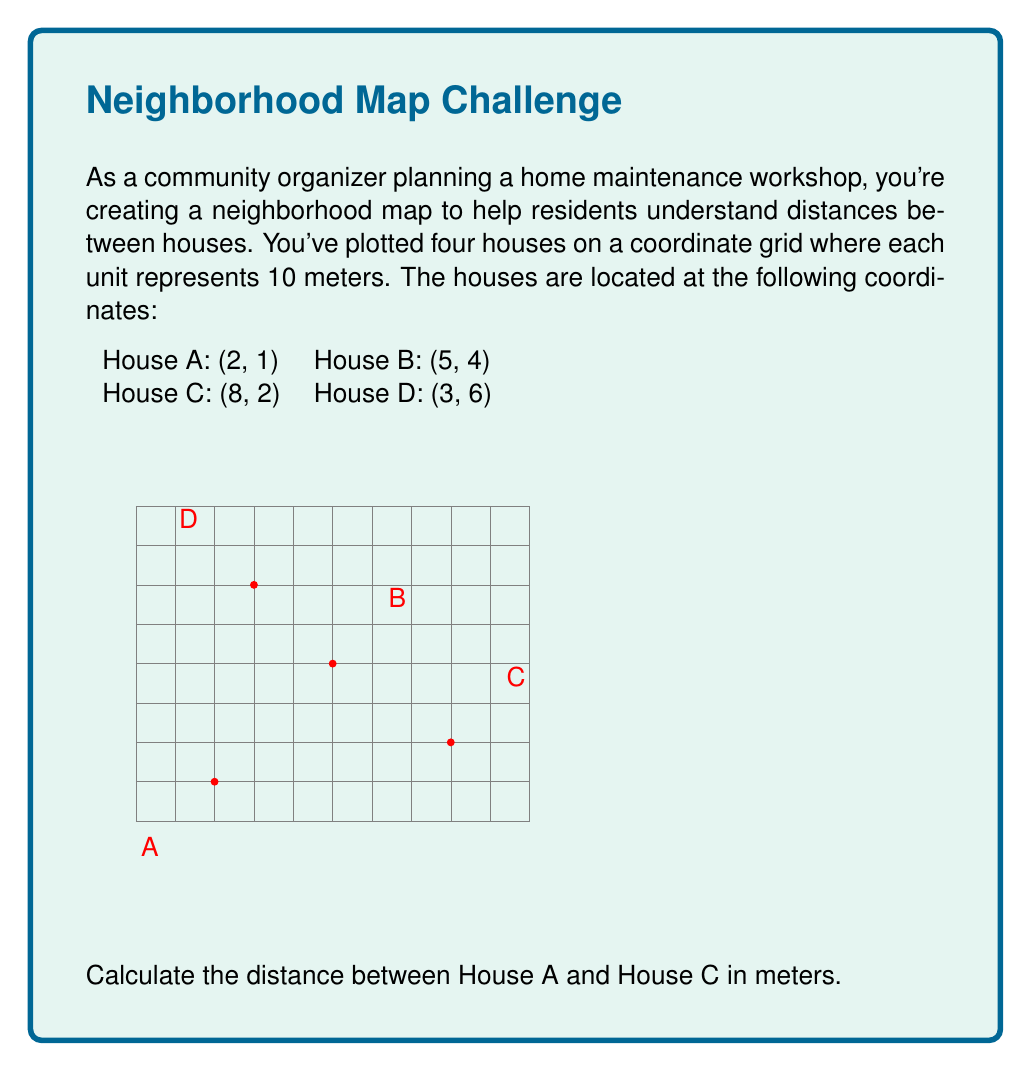Teach me how to tackle this problem. To find the distance between two points on a coordinate plane, we can use the distance formula:

$$d = \sqrt{(x_2-x_1)^2 + (y_2-y_1)^2}$$

Where $(x_1,y_1)$ are the coordinates of the first point and $(x_2,y_2)$ are the coordinates of the second point.

For House A (2,1) and House C (8,2):

1) Plug the values into the formula:
   $$d = \sqrt{(8-2)^2 + (2-1)^2}$$

2) Simplify inside the parentheses:
   $$d = \sqrt{6^2 + 1^2}$$

3) Calculate the squares:
   $$d = \sqrt{36 + 1}$$

4) Add under the square root:
   $$d = \sqrt{37}$$

5) Simplify:
   $$d = \sqrt{37} \approx 6.08$$

6) Since each unit represents 10 meters, multiply the result by 10:
   $$6.08 \times 10 = 60.8$$

Therefore, the distance between House A and House C is approximately 60.8 meters.
Answer: 60.8 meters 